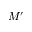<formula> <loc_0><loc_0><loc_500><loc_500>M ^ { \prime }</formula> 